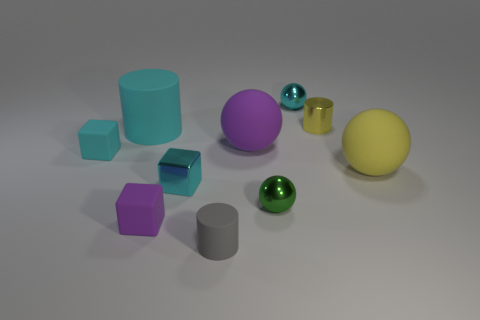There is a gray thing that is made of the same material as the large purple thing; what size is it?
Your answer should be compact. Small. Is the size of the gray object the same as the yellow thing in front of the big purple matte ball?
Offer a very short reply. No. There is a sphere behind the tiny yellow metallic object; what is its material?
Provide a short and direct response. Metal. How many tiny cyan spheres are right of the tiny ball to the left of the cyan metal ball?
Keep it short and to the point. 1. Is there a tiny cyan shiny thing of the same shape as the gray matte thing?
Make the answer very short. No. There is a matte cylinder in front of the green sphere; is it the same size as the cyan object that is to the right of the gray cylinder?
Make the answer very short. Yes. There is a purple rubber thing right of the cyan metallic thing in front of the yellow metallic thing; what is its shape?
Keep it short and to the point. Sphere. What number of rubber blocks have the same size as the green metallic sphere?
Provide a short and direct response. 2. Is there a yellow metallic object?
Your answer should be very brief. Yes. Is there any other thing that has the same color as the metallic cylinder?
Make the answer very short. Yes. 